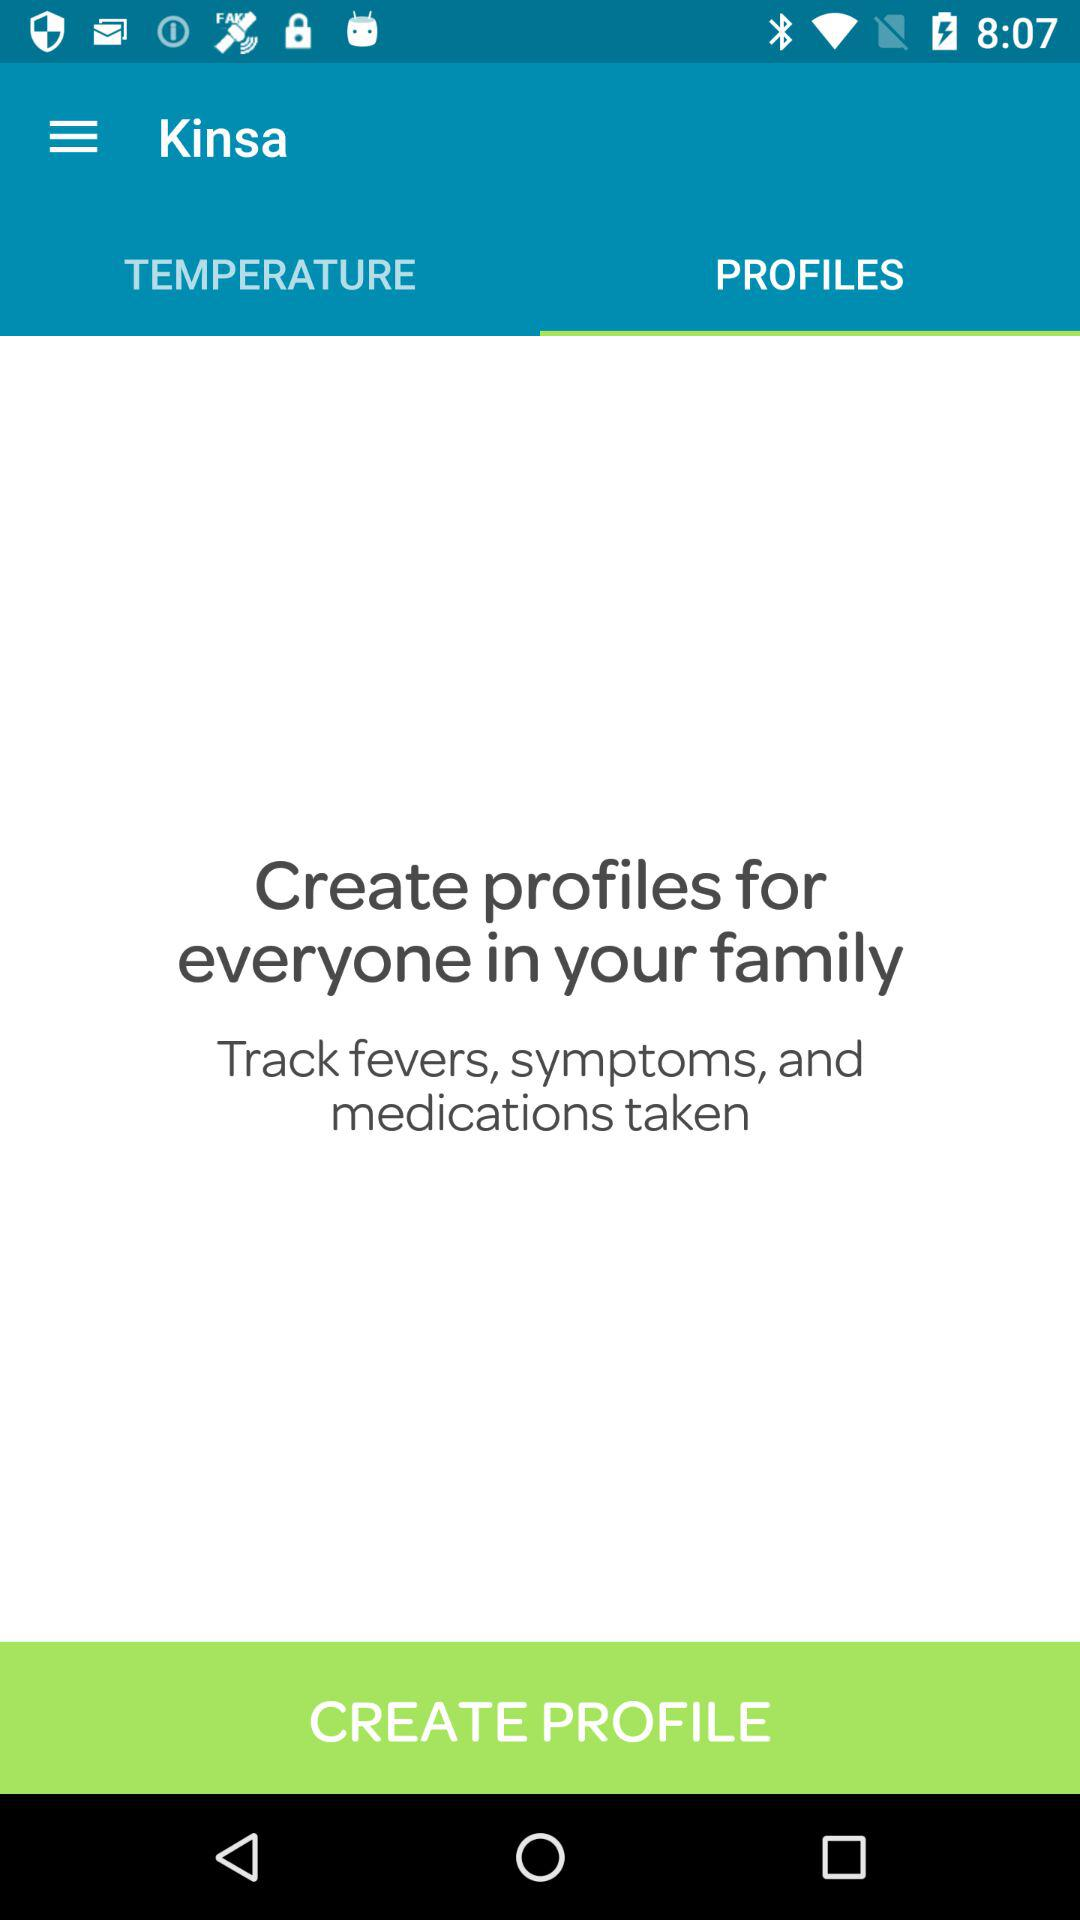What are the temperatures listed?
When the provided information is insufficient, respond with <no answer>. <no answer> 